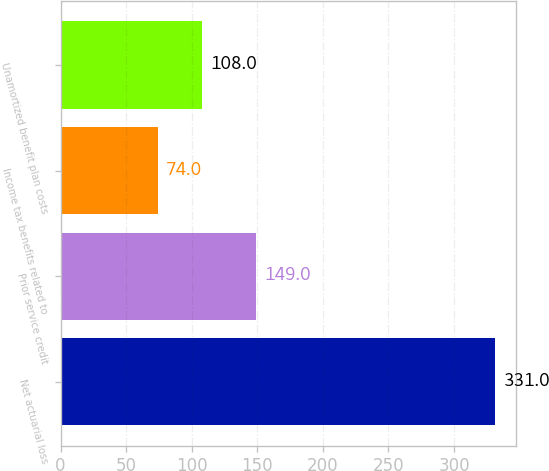<chart> <loc_0><loc_0><loc_500><loc_500><bar_chart><fcel>Net actuarial loss<fcel>Prior service credit<fcel>Income tax benefits related to<fcel>Unamortized benefit plan costs<nl><fcel>331<fcel>149<fcel>74<fcel>108<nl></chart> 